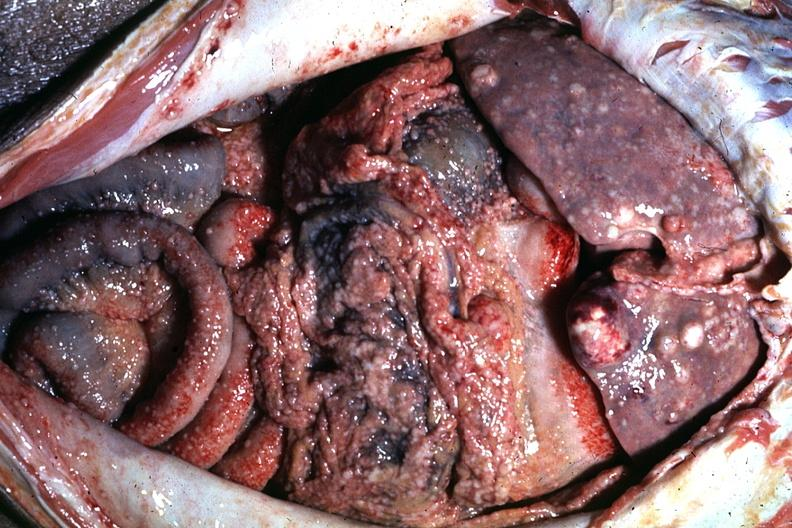where is this area in the body?
Answer the question using a single word or phrase. Abdomen 